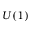<formula> <loc_0><loc_0><loc_500><loc_500>U ( 1 )</formula> 